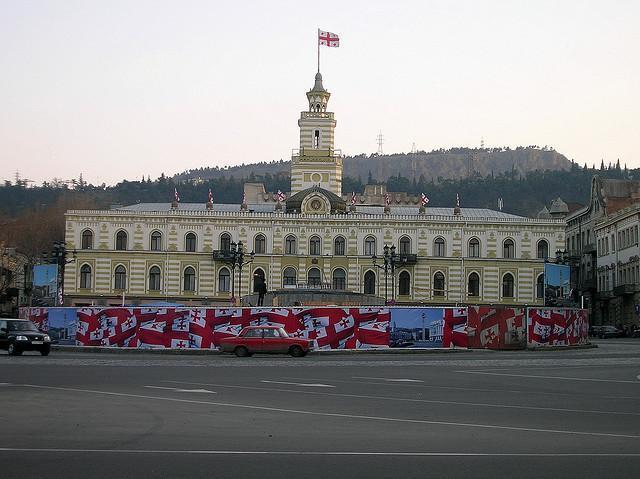How many wheels does the skateboard have?
Give a very brief answer. 0. 